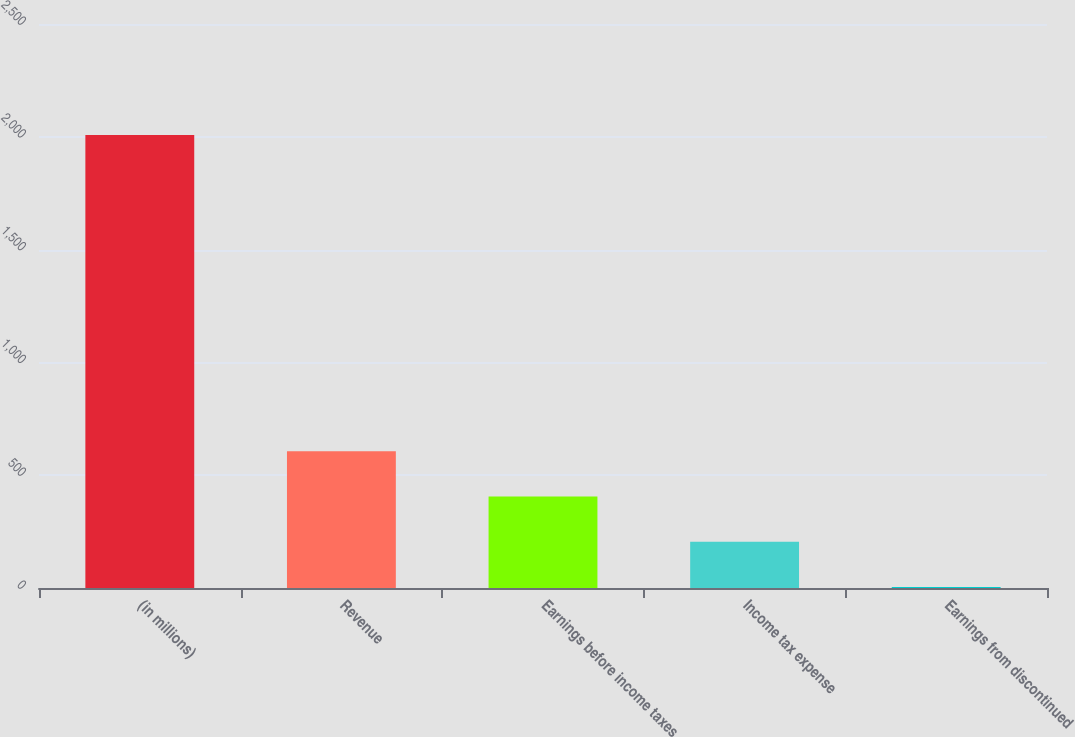Convert chart. <chart><loc_0><loc_0><loc_500><loc_500><bar_chart><fcel>(in millions)<fcel>Revenue<fcel>Earnings before income taxes<fcel>Income tax expense<fcel>Earnings from discontinued<nl><fcel>2008<fcel>605.62<fcel>405.28<fcel>204.94<fcel>4.6<nl></chart> 